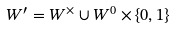<formula> <loc_0><loc_0><loc_500><loc_500>W ^ { \prime } = W ^ { \times } \cup W ^ { 0 } \times \{ 0 , 1 \}</formula> 